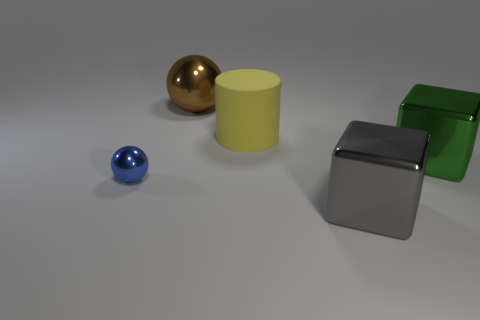Add 5 cylinders. How many objects exist? 10 Subtract all cylinders. How many objects are left? 4 Subtract 0 brown cylinders. How many objects are left? 5 Subtract all metal things. Subtract all gray blocks. How many objects are left? 0 Add 3 big shiny objects. How many big shiny objects are left? 6 Add 5 big rubber things. How many big rubber things exist? 6 